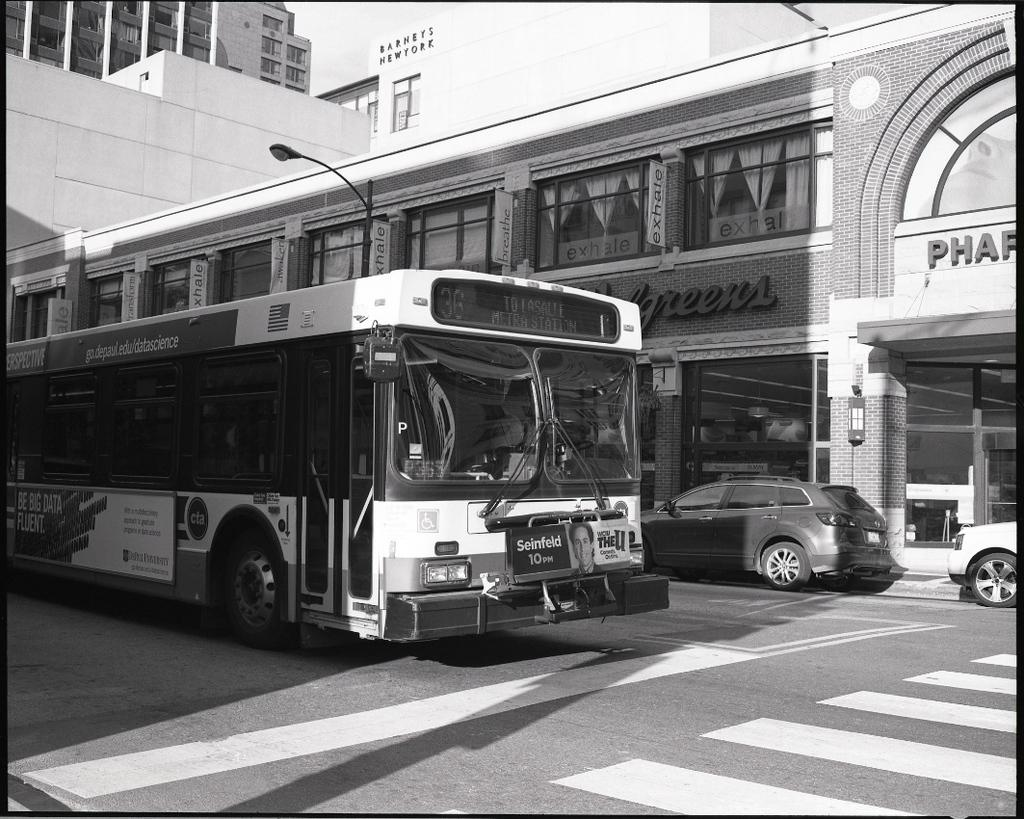What is the main subject of the image? There is a bus in the image. What else can be seen on the road in the image? There are cars on the road in the image. What is visible in the background of the image? There are buildings and a pole in the background of the image. What type of linen is draped over the bus in the image? There is no linen draped over the bus in the image. How many cows can be seen grazing near the bus in the image? There are no cows present in the image. 